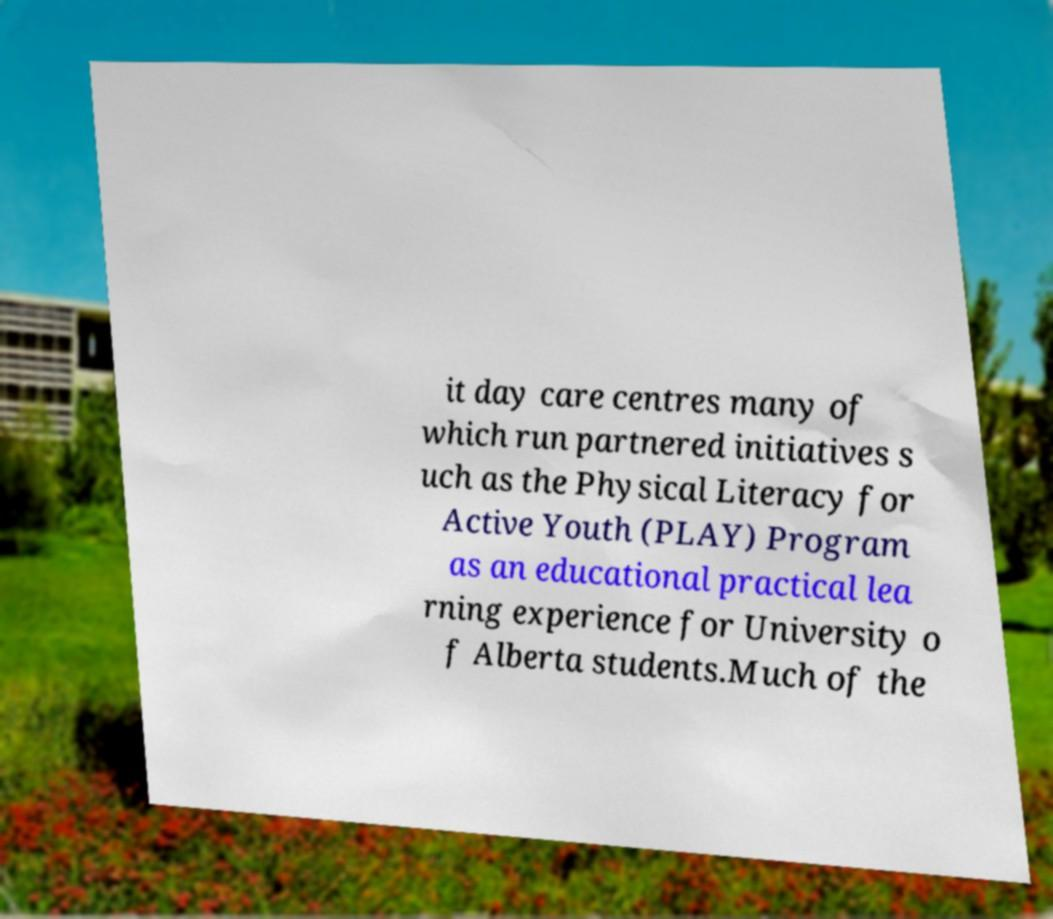Could you assist in decoding the text presented in this image and type it out clearly? it day care centres many of which run partnered initiatives s uch as the Physical Literacy for Active Youth (PLAY) Program as an educational practical lea rning experience for University o f Alberta students.Much of the 